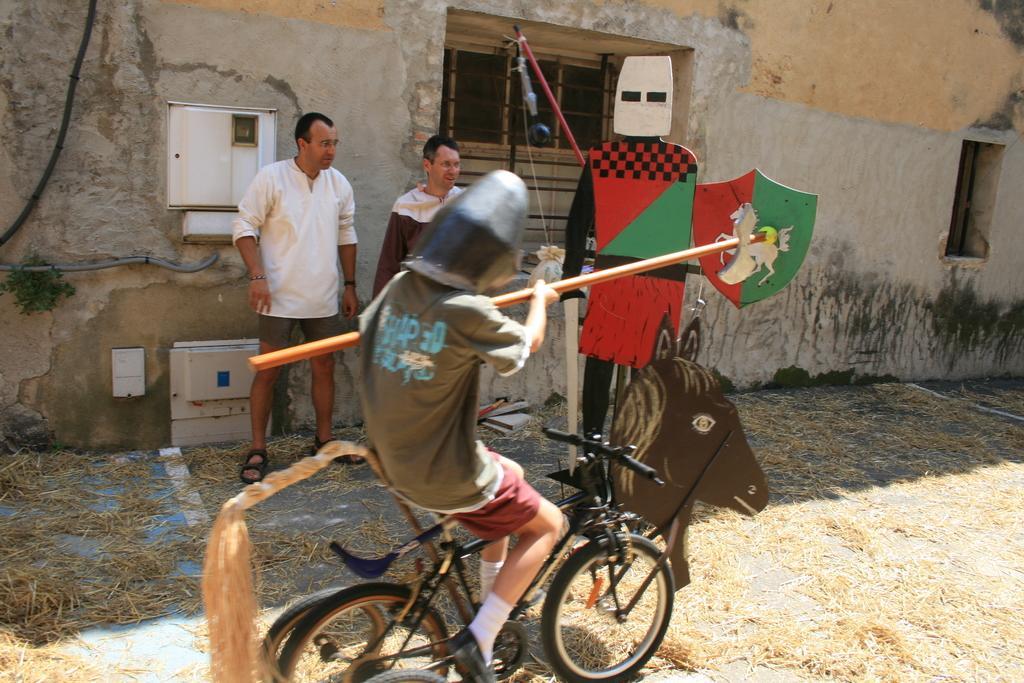How would you summarize this image in a sentence or two? Boy in green t-shirt is riding bicycle. Beside him, we see two men standing near the window. Behind him, we see a wall and in front of them, we see a doll which is made of cardboard and on bottom of picture, we see dry grass. 